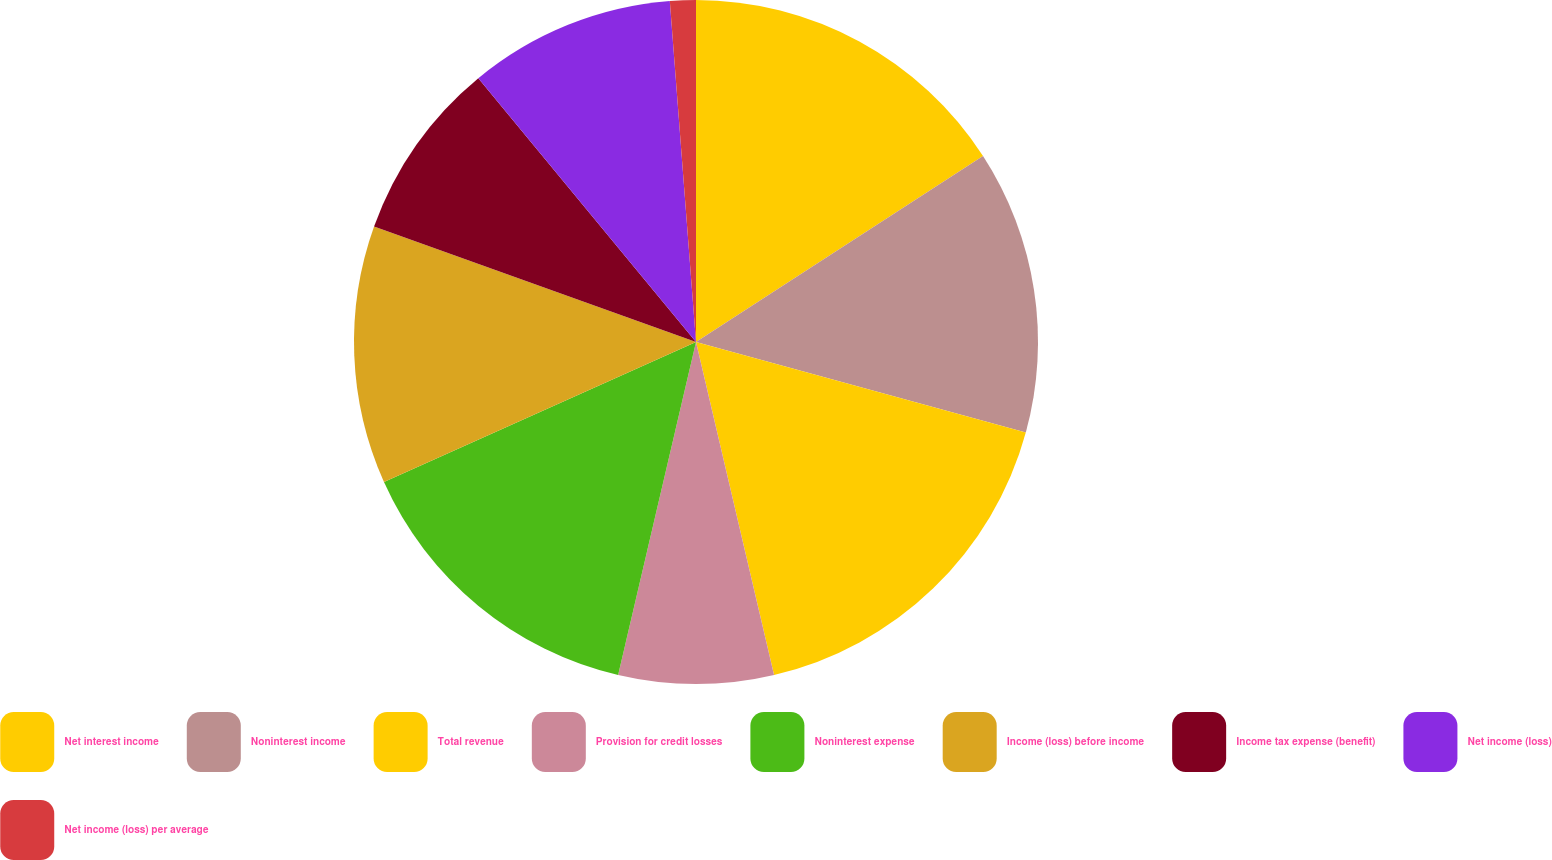Convert chart to OTSL. <chart><loc_0><loc_0><loc_500><loc_500><pie_chart><fcel>Net interest income<fcel>Noninterest income<fcel>Total revenue<fcel>Provision for credit losses<fcel>Noninterest expense<fcel>Income (loss) before income<fcel>Income tax expense (benefit)<fcel>Net income (loss)<fcel>Net income (loss) per average<nl><fcel>15.85%<fcel>13.41%<fcel>17.07%<fcel>7.32%<fcel>14.63%<fcel>12.19%<fcel>8.54%<fcel>9.76%<fcel>1.22%<nl></chart> 